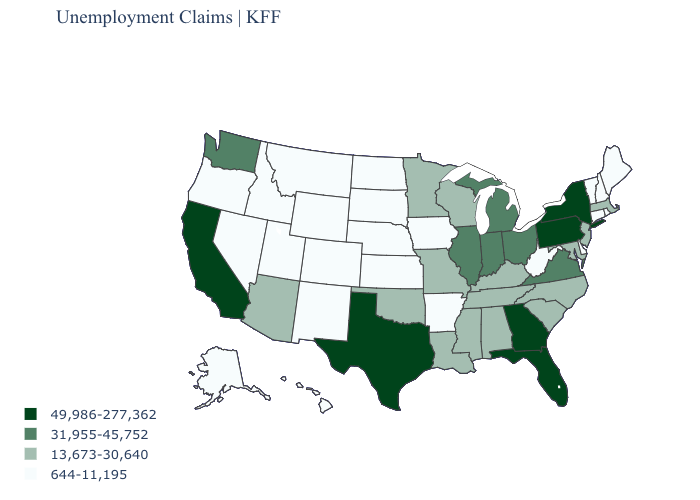How many symbols are there in the legend?
Short answer required. 4. Does California have the lowest value in the West?
Give a very brief answer. No. Which states have the lowest value in the South?
Answer briefly. Arkansas, Delaware, West Virginia. Which states hav the highest value in the West?
Answer briefly. California. What is the value of Oregon?
Be succinct. 644-11,195. Does Montana have a higher value than Oregon?
Write a very short answer. No. Among the states that border Arizona , which have the highest value?
Quick response, please. California. How many symbols are there in the legend?
Short answer required. 4. Name the states that have a value in the range 31,955-45,752?
Quick response, please. Illinois, Indiana, Michigan, Ohio, Virginia, Washington. Among the states that border South Dakota , which have the highest value?
Write a very short answer. Minnesota. Which states have the lowest value in the West?
Short answer required. Alaska, Colorado, Hawaii, Idaho, Montana, Nevada, New Mexico, Oregon, Utah, Wyoming. What is the highest value in the USA?
Be succinct. 49,986-277,362. What is the lowest value in states that border New York?
Quick response, please. 644-11,195. What is the highest value in the USA?
Keep it brief. 49,986-277,362. What is the value of New Hampshire?
Concise answer only. 644-11,195. 